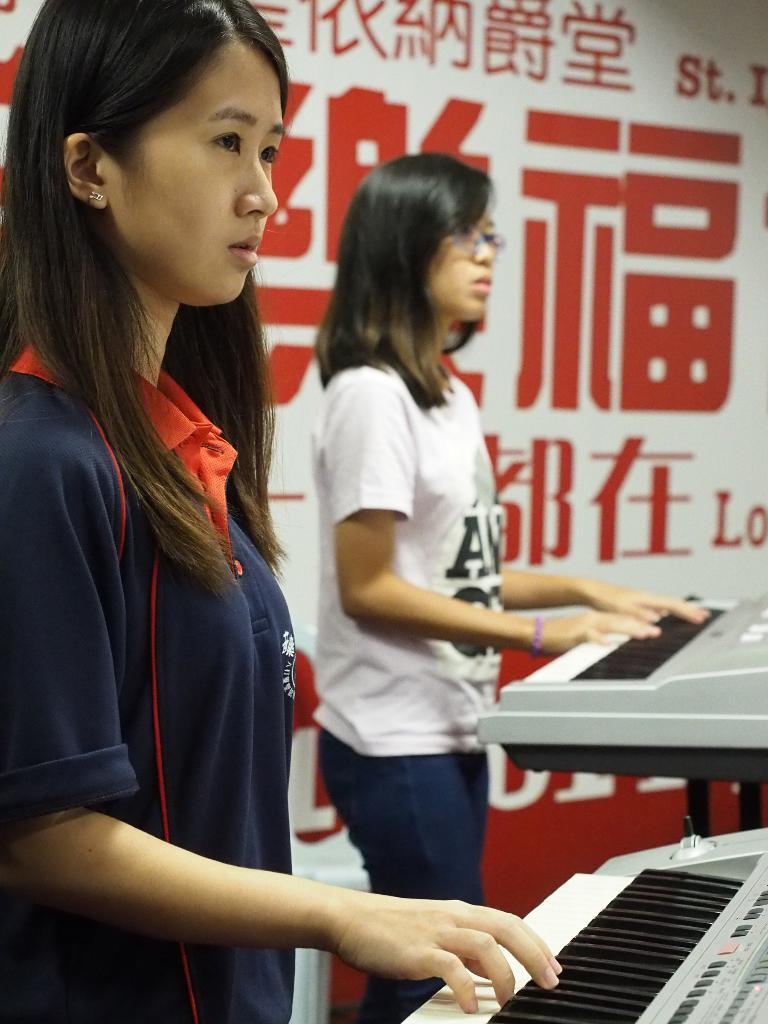What is hanging or displayed in the image? There is a banner in the image. How many people are present in the image? There are two people in the image. What are the two people doing in the image? The two people are standing and playing musical keyboards. What type of oil can be seen dripping from the banner in the image? There is no oil present in the image, and the banner does not appear to be dripping anything. What color is the boot worn by one of the people playing musical keyboards? There is no boot visible in the image, as both people are standing and playing musical keyboards without any footwear mentioned. 